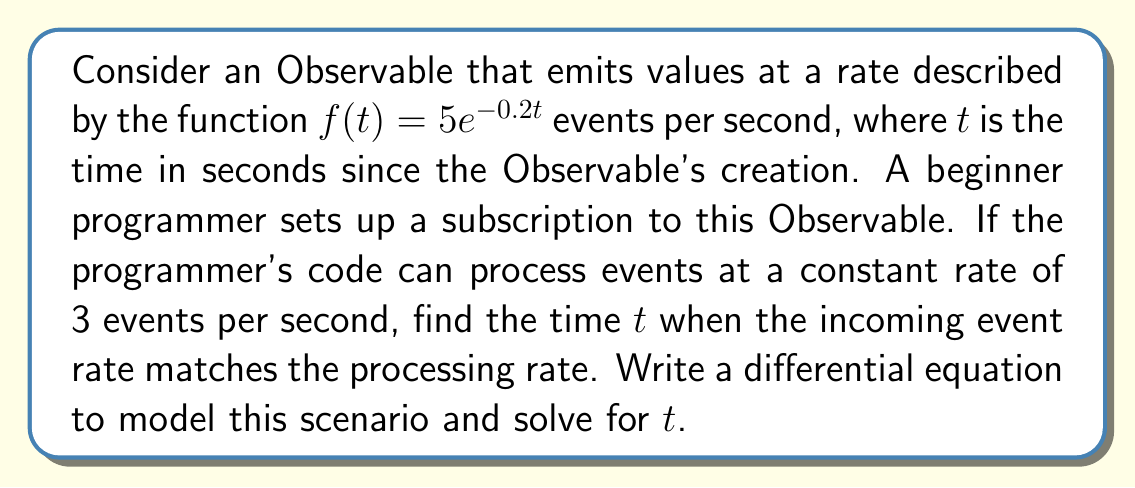Can you solve this math problem? Let's approach this step-by-step:

1) The rate of incoming events is given by $f(t) = 5e^{-0.2t}$ events per second.

2) The processing rate is constant at 3 events per second.

3) We want to find the time $t$ when these rates are equal. This can be expressed as an equation:

   $5e^{-0.2t} = 3$

4) To solve this, we can take the natural logarithm of both sides:

   $\ln(5e^{-0.2t}) = \ln(3)$

5) Using the properties of logarithms:

   $\ln(5) + \ln(e^{-0.2t}) = \ln(3)$

6) Simplify:

   $\ln(5) - 0.2t = \ln(3)$

7) Subtract $\ln(5)$ from both sides:

   $-0.2t = \ln(3) - \ln(5)$

8) Divide both sides by -0.2:

   $t = \frac{\ln(5) - \ln(3)}{0.2}$

9) Calculate the final value:

   $t \approx 2.59$ seconds

To model this as a differential equation, we can consider the difference between the incoming rate and the processing rate:

$$\frac{dN}{dt} = 5e^{-0.2t} - 3$$

where $N$ is the number of unprocessed events. When $\frac{dN}{dt} = 0$, the rates are equal, which occurs at the time $t$ we calculated above.
Answer: The time when the incoming event rate matches the processing rate is approximately 2.59 seconds. The differential equation modeling this scenario is $\frac{dN}{dt} = 5e^{-0.2t} - 3$, where $N$ is the number of unprocessed events. 